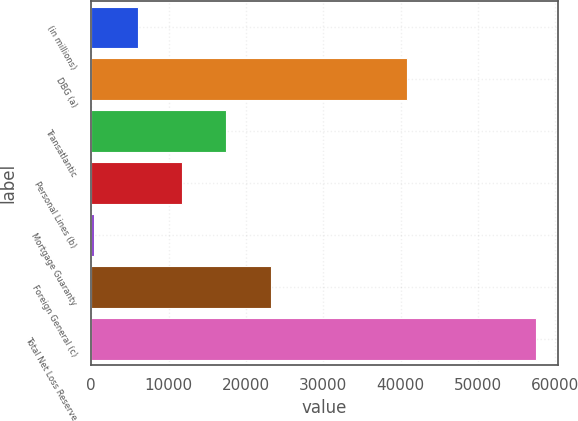Convert chart to OTSL. <chart><loc_0><loc_0><loc_500><loc_500><bar_chart><fcel>(in millions)<fcel>DBG (a)<fcel>Transatlantic<fcel>Personal Lines (b)<fcel>Mortgage Guaranty<fcel>Foreign General (c)<fcel>Total Net Loss Reserve<nl><fcel>6053.6<fcel>40782<fcel>17480.8<fcel>11767.2<fcel>340<fcel>23194.4<fcel>57476<nl></chart> 